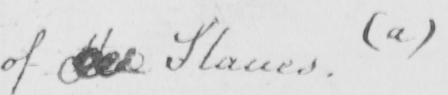Please transcribe the handwritten text in this image. of the Slaves .  ( a ) 